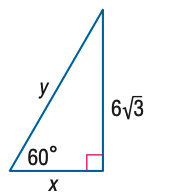Question: Find y.
Choices:
A. 6
B. 12
C. 6 \sqrt { 6 }
D. 12 \sqrt { 3 }
Answer with the letter. Answer: B Question: Find x.
Choices:
A. 6
B. 6 \sqrt { 3 }
C. 12
D. 18
Answer with the letter. Answer: A 